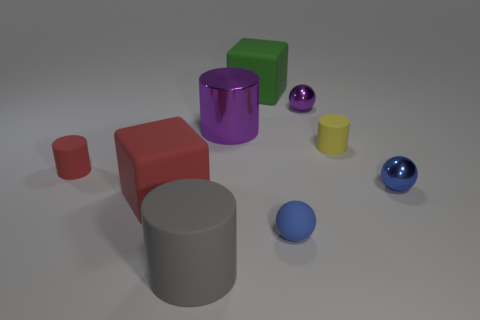What number of cylinders are either big yellow rubber objects or small yellow objects?
Give a very brief answer. 1. What is the material of the tiny thing that is the same color as the rubber ball?
Your answer should be very brief. Metal. Is the shape of the object in front of the small blue rubber ball the same as the purple thing that is left of the rubber sphere?
Ensure brevity in your answer.  Yes. What color is the shiny thing that is behind the tiny red object and to the right of the big metal cylinder?
Ensure brevity in your answer.  Purple. Is the color of the rubber ball the same as the cylinder to the right of the purple metallic ball?
Make the answer very short. No. How big is the rubber cylinder that is right of the big red block and to the left of the green matte thing?
Ensure brevity in your answer.  Large. How many other objects are the same color as the small matte sphere?
Your response must be concise. 1. There is a block behind the small rubber cylinder on the left side of the big block in front of the small yellow object; what is its size?
Provide a short and direct response. Large. There is a big purple metal cylinder; are there any tiny spheres in front of it?
Your answer should be compact. Yes. There is a blue rubber object; does it have the same size as the rubber cylinder in front of the matte ball?
Offer a terse response. No. 